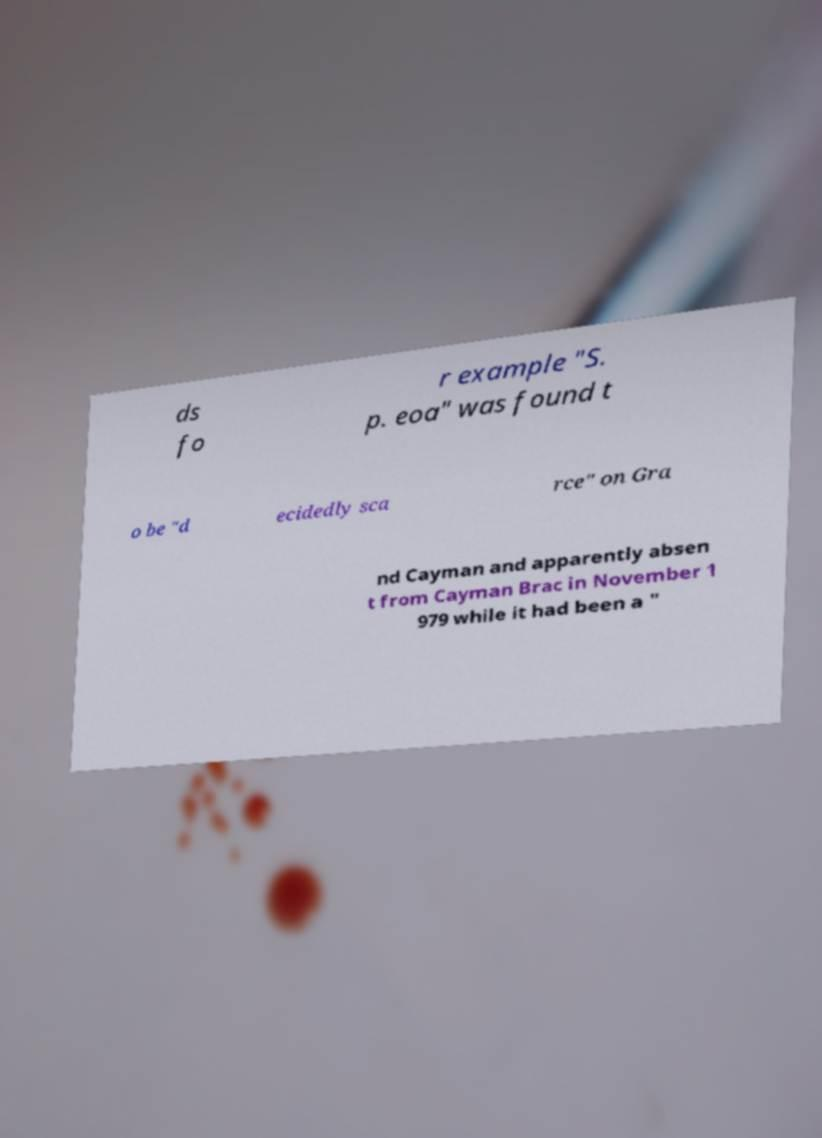Could you assist in decoding the text presented in this image and type it out clearly? ds fo r example "S. p. eoa" was found t o be "d ecidedly sca rce" on Gra nd Cayman and apparently absen t from Cayman Brac in November 1 979 while it had been a " 